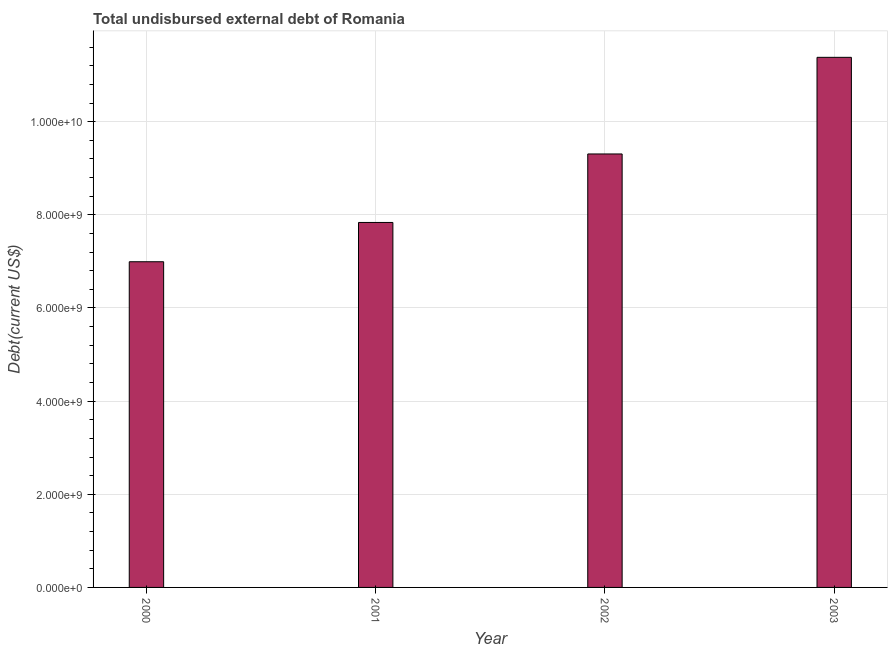Does the graph contain grids?
Offer a terse response. Yes. What is the title of the graph?
Your answer should be very brief. Total undisbursed external debt of Romania. What is the label or title of the X-axis?
Give a very brief answer. Year. What is the label or title of the Y-axis?
Your response must be concise. Debt(current US$). What is the total debt in 2003?
Ensure brevity in your answer.  1.14e+1. Across all years, what is the maximum total debt?
Keep it short and to the point. 1.14e+1. Across all years, what is the minimum total debt?
Make the answer very short. 6.99e+09. What is the sum of the total debt?
Give a very brief answer. 3.55e+1. What is the difference between the total debt in 2000 and 2002?
Give a very brief answer. -2.31e+09. What is the average total debt per year?
Offer a terse response. 8.88e+09. What is the median total debt?
Offer a terse response. 8.57e+09. What is the ratio of the total debt in 2001 to that in 2003?
Your response must be concise. 0.69. Is the difference between the total debt in 2000 and 2003 greater than the difference between any two years?
Make the answer very short. Yes. What is the difference between the highest and the second highest total debt?
Your answer should be compact. 2.07e+09. Is the sum of the total debt in 2000 and 2001 greater than the maximum total debt across all years?
Your response must be concise. Yes. What is the difference between the highest and the lowest total debt?
Offer a terse response. 4.39e+09. In how many years, is the total debt greater than the average total debt taken over all years?
Provide a short and direct response. 2. How many bars are there?
Offer a very short reply. 4. Are all the bars in the graph horizontal?
Give a very brief answer. No. How many years are there in the graph?
Offer a very short reply. 4. What is the difference between two consecutive major ticks on the Y-axis?
Provide a succinct answer. 2.00e+09. What is the Debt(current US$) of 2000?
Your answer should be compact. 6.99e+09. What is the Debt(current US$) of 2001?
Your answer should be compact. 7.84e+09. What is the Debt(current US$) of 2002?
Your answer should be compact. 9.31e+09. What is the Debt(current US$) in 2003?
Your response must be concise. 1.14e+1. What is the difference between the Debt(current US$) in 2000 and 2001?
Provide a succinct answer. -8.44e+08. What is the difference between the Debt(current US$) in 2000 and 2002?
Your response must be concise. -2.31e+09. What is the difference between the Debt(current US$) in 2000 and 2003?
Your response must be concise. -4.39e+09. What is the difference between the Debt(current US$) in 2001 and 2002?
Ensure brevity in your answer.  -1.47e+09. What is the difference between the Debt(current US$) in 2001 and 2003?
Offer a very short reply. -3.55e+09. What is the difference between the Debt(current US$) in 2002 and 2003?
Give a very brief answer. -2.07e+09. What is the ratio of the Debt(current US$) in 2000 to that in 2001?
Provide a succinct answer. 0.89. What is the ratio of the Debt(current US$) in 2000 to that in 2002?
Provide a short and direct response. 0.75. What is the ratio of the Debt(current US$) in 2000 to that in 2003?
Make the answer very short. 0.61. What is the ratio of the Debt(current US$) in 2001 to that in 2002?
Offer a very short reply. 0.84. What is the ratio of the Debt(current US$) in 2001 to that in 2003?
Provide a short and direct response. 0.69. What is the ratio of the Debt(current US$) in 2002 to that in 2003?
Provide a succinct answer. 0.82. 